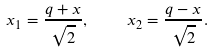<formula> <loc_0><loc_0><loc_500><loc_500>x _ { 1 } = \frac { q + x } { \sqrt { 2 } } , \quad x _ { 2 } = \frac { q - x } { \sqrt { 2 } } .</formula> 